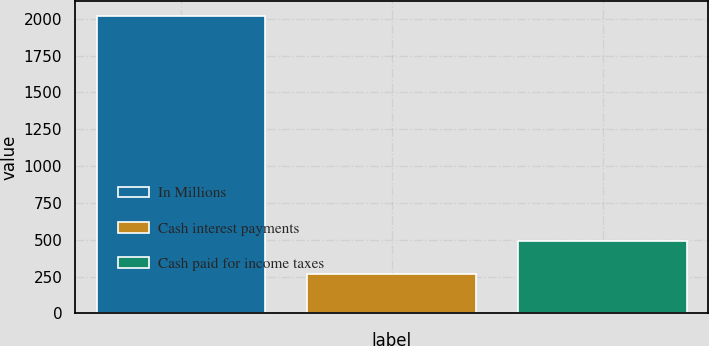Convert chart. <chart><loc_0><loc_0><loc_500><loc_500><bar_chart><fcel>In Millions<fcel>Cash interest payments<fcel>Cash paid for income taxes<nl><fcel>2018<fcel>269.5<fcel>489.4<nl></chart> 